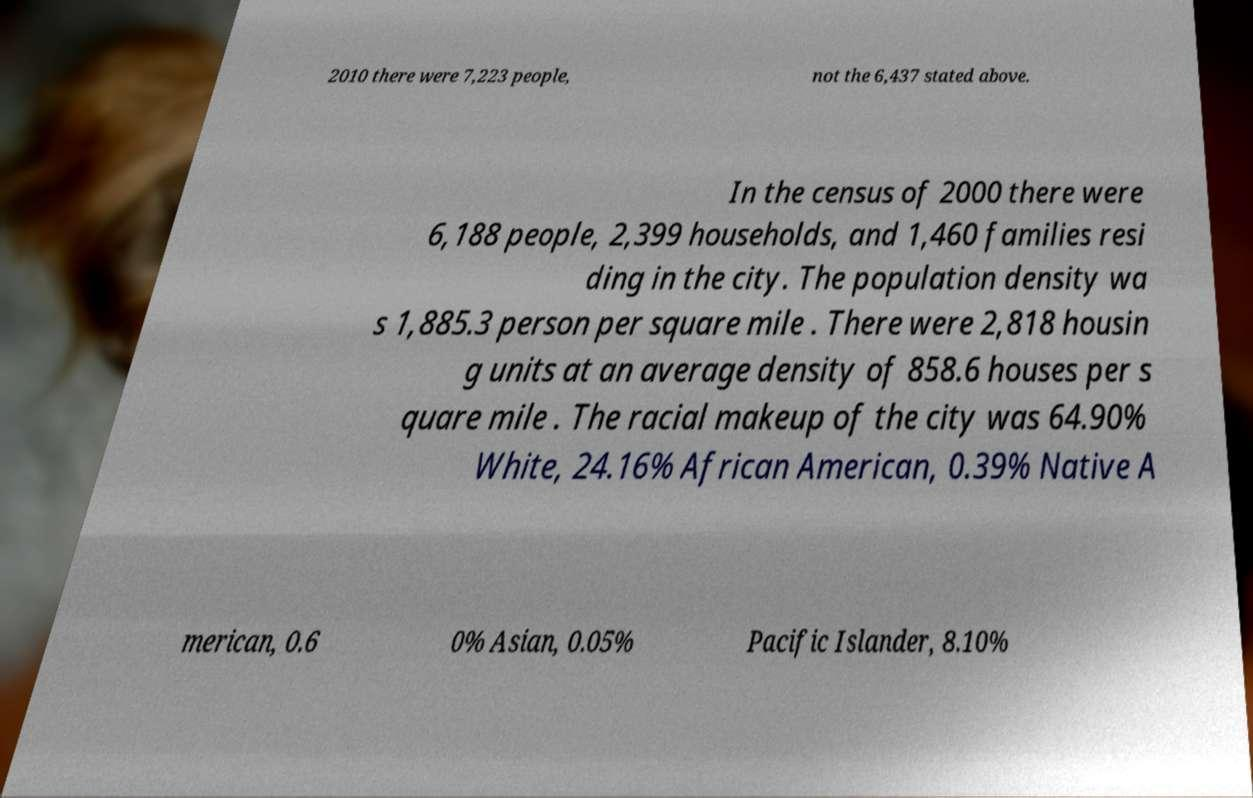Can you read and provide the text displayed in the image?This photo seems to have some interesting text. Can you extract and type it out for me? 2010 there were 7,223 people, not the 6,437 stated above. In the census of 2000 there were 6,188 people, 2,399 households, and 1,460 families resi ding in the city. The population density wa s 1,885.3 person per square mile . There were 2,818 housin g units at an average density of 858.6 houses per s quare mile . The racial makeup of the city was 64.90% White, 24.16% African American, 0.39% Native A merican, 0.6 0% Asian, 0.05% Pacific Islander, 8.10% 